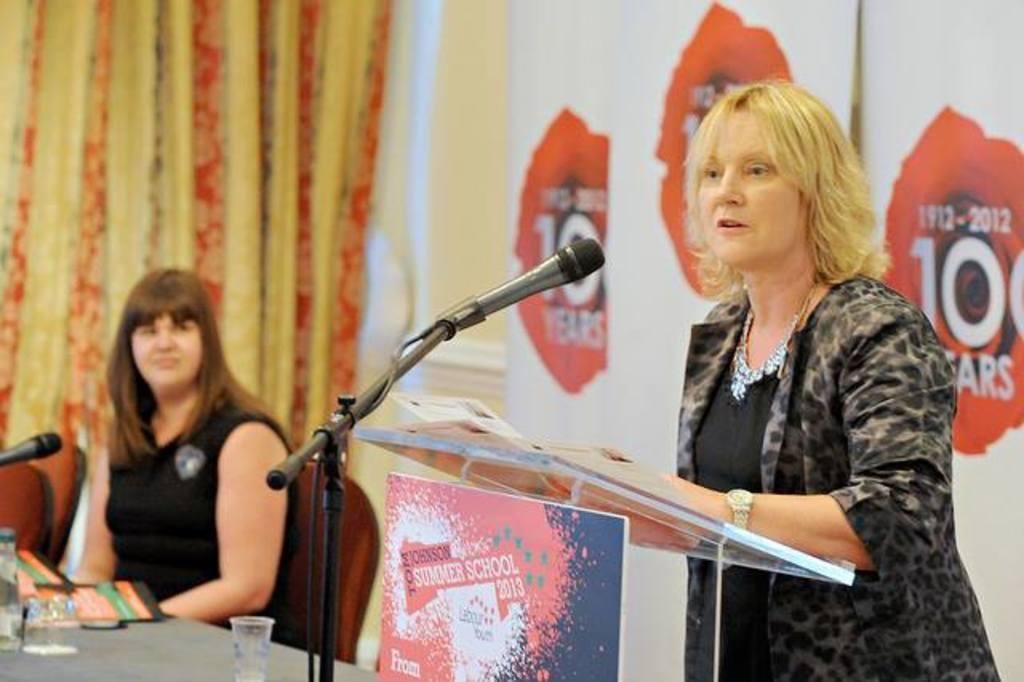Please provide a concise description of this image. In the picture we can see woman wearing black color dress standing behind glass podium on which there are some papers, there is microphone in front of her, on left side of the picture we can see another woman also wearing black color dress sitting on chair behind table on which there are some glasses, bottles, microphone and in the background of the picture there is curtain and there is white color screen. 